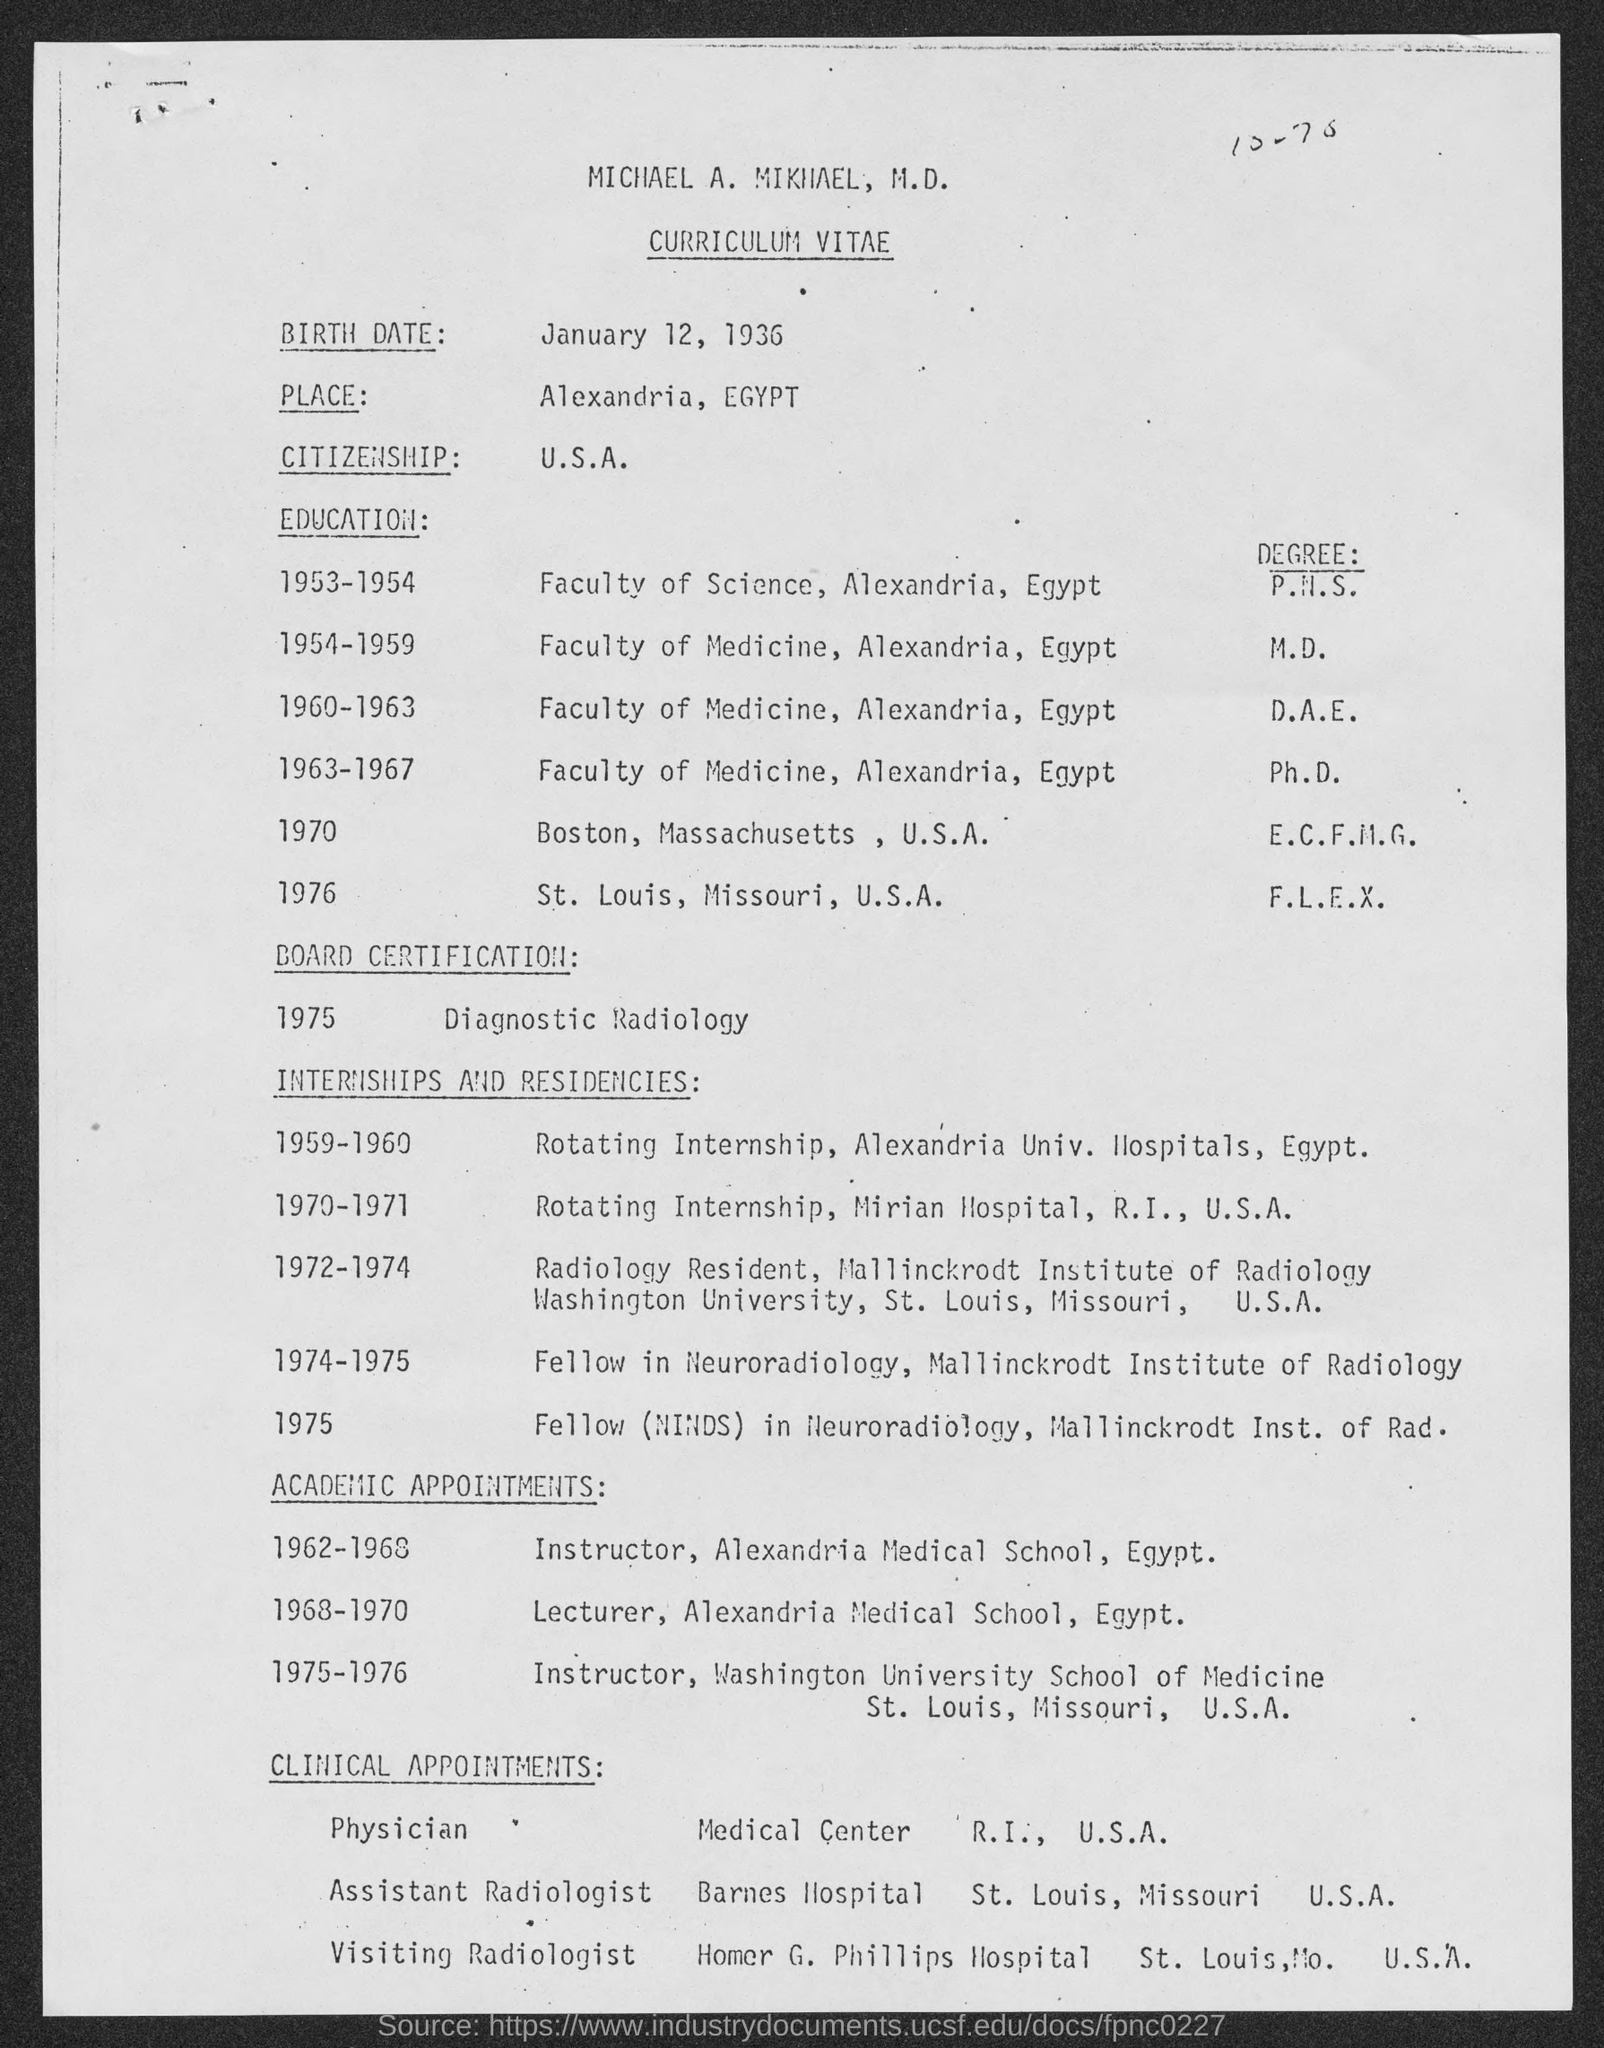Which is the birthdate of Michael A. Mikhael?
Provide a succinct answer. January 12, 1936. Where is the citizenship of Michael?
Make the answer very short. U.S.A. Where has Michael completed degree in F.L.E.X?
Ensure brevity in your answer.  St. Louis, Missouri, U.S.A. 